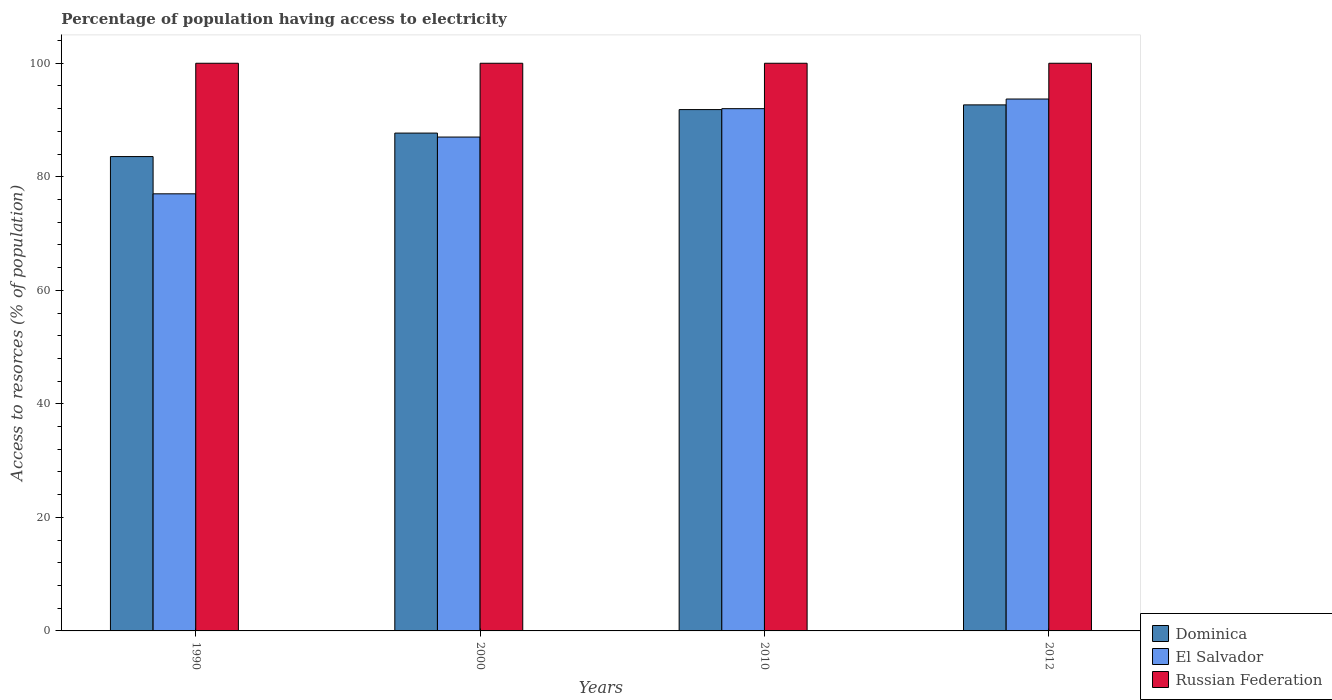Are the number of bars on each tick of the X-axis equal?
Provide a short and direct response. Yes. How many bars are there on the 4th tick from the right?
Your answer should be compact. 3. What is the label of the 1st group of bars from the left?
Make the answer very short. 1990. Across all years, what is the maximum percentage of population having access to electricity in Dominica?
Provide a short and direct response. 92.67. Across all years, what is the minimum percentage of population having access to electricity in Dominica?
Provide a short and direct response. 83.56. What is the total percentage of population having access to electricity in El Salvador in the graph?
Your answer should be compact. 349.7. What is the difference between the percentage of population having access to electricity in El Salvador in 2012 and the percentage of population having access to electricity in Dominica in 1990?
Provide a short and direct response. 10.14. What is the average percentage of population having access to electricity in Russian Federation per year?
Give a very brief answer. 100. In the year 2010, what is the difference between the percentage of population having access to electricity in Dominica and percentage of population having access to electricity in El Salvador?
Keep it short and to the point. -0.16. Is the percentage of population having access to electricity in Russian Federation in 1990 less than that in 2012?
Ensure brevity in your answer.  No. Is the difference between the percentage of population having access to electricity in Dominica in 1990 and 2010 greater than the difference between the percentage of population having access to electricity in El Salvador in 1990 and 2010?
Make the answer very short. Yes. What is the difference between the highest and the second highest percentage of population having access to electricity in Russian Federation?
Make the answer very short. 0. What is the difference between the highest and the lowest percentage of population having access to electricity in Dominica?
Your answer should be very brief. 9.11. Is the sum of the percentage of population having access to electricity in El Salvador in 1990 and 2010 greater than the maximum percentage of population having access to electricity in Dominica across all years?
Offer a very short reply. Yes. What does the 2nd bar from the left in 2012 represents?
Offer a terse response. El Salvador. What does the 2nd bar from the right in 2010 represents?
Your response must be concise. El Salvador. Are all the bars in the graph horizontal?
Your answer should be compact. No. Does the graph contain grids?
Keep it short and to the point. No. Where does the legend appear in the graph?
Your response must be concise. Bottom right. What is the title of the graph?
Your answer should be very brief. Percentage of population having access to electricity. Does "French Polynesia" appear as one of the legend labels in the graph?
Offer a terse response. No. What is the label or title of the X-axis?
Provide a short and direct response. Years. What is the label or title of the Y-axis?
Ensure brevity in your answer.  Access to resorces (% of population). What is the Access to resorces (% of population) in Dominica in 1990?
Your answer should be very brief. 83.56. What is the Access to resorces (% of population) in Dominica in 2000?
Provide a succinct answer. 87.7. What is the Access to resorces (% of population) in El Salvador in 2000?
Your answer should be very brief. 87. What is the Access to resorces (% of population) of Russian Federation in 2000?
Keep it short and to the point. 100. What is the Access to resorces (% of population) in Dominica in 2010?
Offer a very short reply. 91.84. What is the Access to resorces (% of population) in El Salvador in 2010?
Provide a short and direct response. 92. What is the Access to resorces (% of population) of Russian Federation in 2010?
Keep it short and to the point. 100. What is the Access to resorces (% of population) in Dominica in 2012?
Your answer should be very brief. 92.67. What is the Access to resorces (% of population) of El Salvador in 2012?
Make the answer very short. 93.7. What is the Access to resorces (% of population) of Russian Federation in 2012?
Your answer should be very brief. 100. Across all years, what is the maximum Access to resorces (% of population) in Dominica?
Keep it short and to the point. 92.67. Across all years, what is the maximum Access to resorces (% of population) in El Salvador?
Make the answer very short. 93.7. Across all years, what is the maximum Access to resorces (% of population) of Russian Federation?
Provide a succinct answer. 100. Across all years, what is the minimum Access to resorces (% of population) in Dominica?
Offer a terse response. 83.56. Across all years, what is the minimum Access to resorces (% of population) of El Salvador?
Your answer should be very brief. 77. What is the total Access to resorces (% of population) in Dominica in the graph?
Your response must be concise. 355.77. What is the total Access to resorces (% of population) of El Salvador in the graph?
Your answer should be very brief. 349.7. What is the total Access to resorces (% of population) in Russian Federation in the graph?
Offer a terse response. 400. What is the difference between the Access to resorces (% of population) of Dominica in 1990 and that in 2000?
Ensure brevity in your answer.  -4.14. What is the difference between the Access to resorces (% of population) in El Salvador in 1990 and that in 2000?
Provide a succinct answer. -10. What is the difference between the Access to resorces (% of population) of Russian Federation in 1990 and that in 2000?
Make the answer very short. 0. What is the difference between the Access to resorces (% of population) in Dominica in 1990 and that in 2010?
Give a very brief answer. -8.28. What is the difference between the Access to resorces (% of population) in El Salvador in 1990 and that in 2010?
Keep it short and to the point. -15. What is the difference between the Access to resorces (% of population) in Dominica in 1990 and that in 2012?
Your response must be concise. -9.11. What is the difference between the Access to resorces (% of population) in El Salvador in 1990 and that in 2012?
Ensure brevity in your answer.  -16.7. What is the difference between the Access to resorces (% of population) of Dominica in 2000 and that in 2010?
Offer a terse response. -4.14. What is the difference between the Access to resorces (% of population) in El Salvador in 2000 and that in 2010?
Give a very brief answer. -5. What is the difference between the Access to resorces (% of population) in Dominica in 2000 and that in 2012?
Provide a succinct answer. -4.97. What is the difference between the Access to resorces (% of population) of Dominica in 2010 and that in 2012?
Your response must be concise. -0.83. What is the difference between the Access to resorces (% of population) of Dominica in 1990 and the Access to resorces (% of population) of El Salvador in 2000?
Keep it short and to the point. -3.44. What is the difference between the Access to resorces (% of population) of Dominica in 1990 and the Access to resorces (% of population) of Russian Federation in 2000?
Keep it short and to the point. -16.44. What is the difference between the Access to resorces (% of population) in Dominica in 1990 and the Access to resorces (% of population) in El Salvador in 2010?
Make the answer very short. -8.44. What is the difference between the Access to resorces (% of population) in Dominica in 1990 and the Access to resorces (% of population) in Russian Federation in 2010?
Your answer should be very brief. -16.44. What is the difference between the Access to resorces (% of population) in El Salvador in 1990 and the Access to resorces (% of population) in Russian Federation in 2010?
Offer a terse response. -23. What is the difference between the Access to resorces (% of population) of Dominica in 1990 and the Access to resorces (% of population) of El Salvador in 2012?
Offer a very short reply. -10.14. What is the difference between the Access to resorces (% of population) in Dominica in 1990 and the Access to resorces (% of population) in Russian Federation in 2012?
Make the answer very short. -16.44. What is the difference between the Access to resorces (% of population) in Dominica in 2000 and the Access to resorces (% of population) in El Salvador in 2010?
Give a very brief answer. -4.3. What is the difference between the Access to resorces (% of population) in Dominica in 2000 and the Access to resorces (% of population) in Russian Federation in 2010?
Offer a terse response. -12.3. What is the difference between the Access to resorces (% of population) of Dominica in 2000 and the Access to resorces (% of population) of El Salvador in 2012?
Ensure brevity in your answer.  -6. What is the difference between the Access to resorces (% of population) of Dominica in 2010 and the Access to resorces (% of population) of El Salvador in 2012?
Give a very brief answer. -1.86. What is the difference between the Access to resorces (% of population) of Dominica in 2010 and the Access to resorces (% of population) of Russian Federation in 2012?
Provide a succinct answer. -8.16. What is the difference between the Access to resorces (% of population) of El Salvador in 2010 and the Access to resorces (% of population) of Russian Federation in 2012?
Keep it short and to the point. -8. What is the average Access to resorces (% of population) of Dominica per year?
Provide a short and direct response. 88.94. What is the average Access to resorces (% of population) of El Salvador per year?
Offer a terse response. 87.42. What is the average Access to resorces (% of population) in Russian Federation per year?
Make the answer very short. 100. In the year 1990, what is the difference between the Access to resorces (% of population) in Dominica and Access to resorces (% of population) in El Salvador?
Offer a very short reply. 6.56. In the year 1990, what is the difference between the Access to resorces (% of population) of Dominica and Access to resorces (% of population) of Russian Federation?
Make the answer very short. -16.44. In the year 2010, what is the difference between the Access to resorces (% of population) in Dominica and Access to resorces (% of population) in El Salvador?
Keep it short and to the point. -0.16. In the year 2010, what is the difference between the Access to resorces (% of population) of Dominica and Access to resorces (% of population) of Russian Federation?
Ensure brevity in your answer.  -8.16. In the year 2012, what is the difference between the Access to resorces (% of population) of Dominica and Access to resorces (% of population) of El Salvador?
Offer a very short reply. -1.03. In the year 2012, what is the difference between the Access to resorces (% of population) of Dominica and Access to resorces (% of population) of Russian Federation?
Your answer should be compact. -7.33. In the year 2012, what is the difference between the Access to resorces (% of population) in El Salvador and Access to resorces (% of population) in Russian Federation?
Your answer should be compact. -6.3. What is the ratio of the Access to resorces (% of population) in Dominica in 1990 to that in 2000?
Offer a terse response. 0.95. What is the ratio of the Access to resorces (% of population) in El Salvador in 1990 to that in 2000?
Ensure brevity in your answer.  0.89. What is the ratio of the Access to resorces (% of population) in Dominica in 1990 to that in 2010?
Make the answer very short. 0.91. What is the ratio of the Access to resorces (% of population) in El Salvador in 1990 to that in 2010?
Your answer should be compact. 0.84. What is the ratio of the Access to resorces (% of population) of Russian Federation in 1990 to that in 2010?
Your response must be concise. 1. What is the ratio of the Access to resorces (% of population) in Dominica in 1990 to that in 2012?
Your response must be concise. 0.9. What is the ratio of the Access to resorces (% of population) of El Salvador in 1990 to that in 2012?
Provide a succinct answer. 0.82. What is the ratio of the Access to resorces (% of population) of Russian Federation in 1990 to that in 2012?
Offer a very short reply. 1. What is the ratio of the Access to resorces (% of population) of Dominica in 2000 to that in 2010?
Give a very brief answer. 0.95. What is the ratio of the Access to resorces (% of population) in El Salvador in 2000 to that in 2010?
Provide a succinct answer. 0.95. What is the ratio of the Access to resorces (% of population) in Russian Federation in 2000 to that in 2010?
Offer a terse response. 1. What is the ratio of the Access to resorces (% of population) in Dominica in 2000 to that in 2012?
Offer a terse response. 0.95. What is the ratio of the Access to resorces (% of population) in El Salvador in 2000 to that in 2012?
Offer a very short reply. 0.93. What is the ratio of the Access to resorces (% of population) in Dominica in 2010 to that in 2012?
Your answer should be very brief. 0.99. What is the ratio of the Access to resorces (% of population) in El Salvador in 2010 to that in 2012?
Make the answer very short. 0.98. What is the difference between the highest and the second highest Access to resorces (% of population) of Dominica?
Offer a terse response. 0.83. What is the difference between the highest and the second highest Access to resorces (% of population) of El Salvador?
Your answer should be compact. 1.7. What is the difference between the highest and the lowest Access to resorces (% of population) in Dominica?
Offer a very short reply. 9.11. What is the difference between the highest and the lowest Access to resorces (% of population) of El Salvador?
Provide a succinct answer. 16.7. What is the difference between the highest and the lowest Access to resorces (% of population) in Russian Federation?
Provide a succinct answer. 0. 